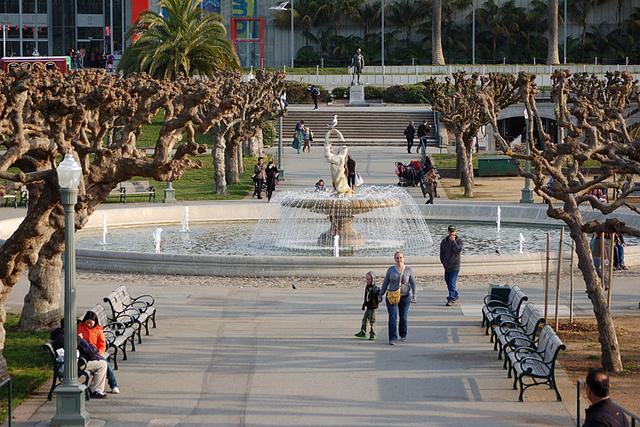From the quality of the shadows, does the sky appear to be clear or overcast (or cloudy)?
Short answer required. Clear. How many benches are on the right?
Answer briefly. 3. What liquid is in the center of the photo?
Answer briefly. Water. 